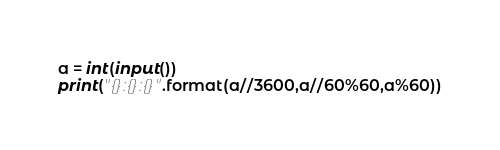<code> <loc_0><loc_0><loc_500><loc_500><_Python_>a = int(input())
print("{}:{}:{}".format(a//3600,a//60%60,a%60))
</code> 